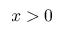Convert formula to latex. <formula><loc_0><loc_0><loc_500><loc_500>x > 0</formula> 